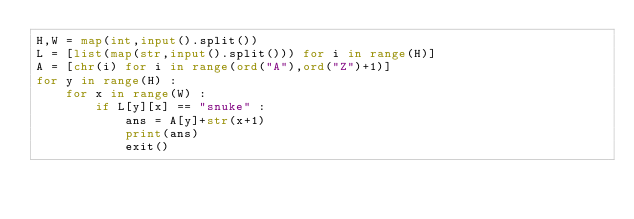<code> <loc_0><loc_0><loc_500><loc_500><_Python_>H,W = map(int,input().split())
L = [list(map(str,input().split())) for i in range(H)]
A = [chr(i) for i in range(ord("A"),ord("Z")+1)]
for y in range(H) :
    for x in range(W) :
        if L[y][x] == "snuke" :
            ans = A[y]+str(x+1)
            print(ans)
            exit()
            </code> 